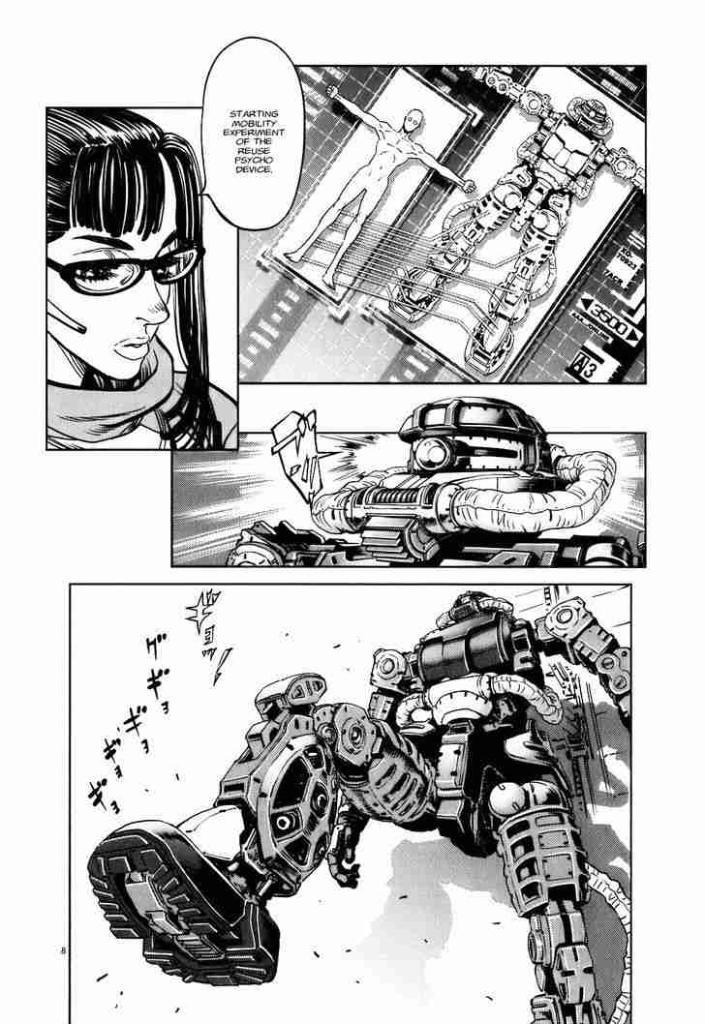Can you describe this image briefly? This is an edited picture. In this image there are pictures of robots and there is a picture of a woman and there is text. At the back there is a white background. 